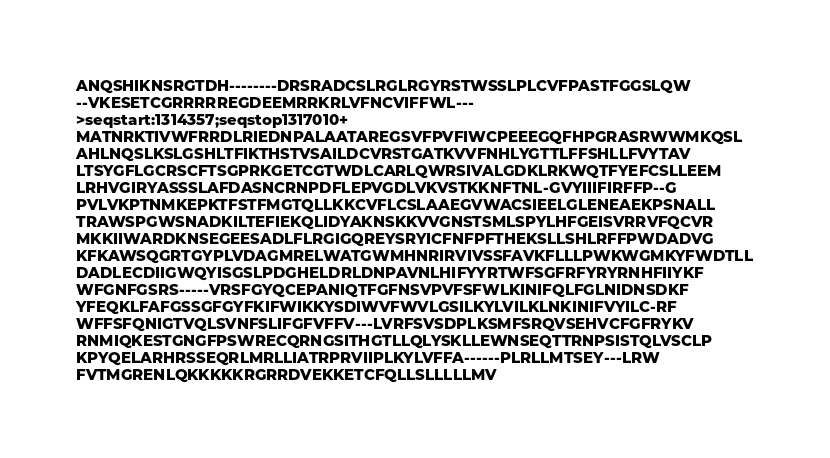<code> <loc_0><loc_0><loc_500><loc_500><_Perl_>ANQSHIKNSRGTDH--------DRSRADCSLRGLRGYRSTWSSLPLCVFPASTFGGSLQW
--VKESETCGRRRRREGDEEMRRKRLVFNCVIFFWL---
>seqstart:1314357;seqstop1317010+
MATNRKTIVWFRRDLRIEDNPALAATAREGSVFPVFIWCPEEEGQFHPGRASRWWMKQSL
AHLNQSLKSLGSHLTFIKTHSTVSAILDCVRSTGATKVVFNHLYGTTLFFSHLLFVYTAV
LTSYGFLGCRSCFTSGPRKGETCGTWDLCARLQWRSIVALGDKLRKWQTFYEFCSLLEEM
LRHVGIRYASSSLAFDASNCRNPDFLEPVGDLVKVSTKKNFTNL-GVYIIIFIRFFP--G
PVLVKPTNMKEPKTFSTFMGTQLLKKCVFLCSLAAEGVWACSIEELGLENEAEKPSNALL
TRAWSPGWSNADKILTEFIEKQLIDYAKNSKKVVGNSTSMLSPYLHFGEISVRRVFQCVR
MKKIIWARDKNSEGEESADLFLRGIGQREYSRYICFNFPFTHEKSLLSHLRFFPWDADVG
KFKAWSQGRTGYPLVDAGMRELWATGWMHNRIRVIVSSFAVKFLLLPWKWGMKYFWDTLL
DADLECDIIGWQYISGSLPDGHELDRLDNPAVNLHIFYYRTWFSGFRFYRYRNHFIIYKF
WFGNFGSRS-----VRSFGYQCEPANIQTFGFNSVPVFSFWLKINIFQLFGLNIDNSDKF
YFEQKLFAFGSSGFGYFKIFWIKKYSDIWVFWVLGSILKYLVILKLNKINIFVYILC-RF
WFFSFQNIGTVQLSVNFSLIFGFVFFV---LVRFSVSDPLKSMFSRQVSEHVCFGFRYKV
RNMIQKESTGNGFPSWRECQRNGSITHGTLLQLYSKLLEWNSEQTTRNPSISTQLVSCLP
KPYQELARHRSSEQRLMRLLIATRPRVIIPLKYLVFFA------PLRLLMTSEY---LRW
FVTMGRENLQKKKKKRGRRDVEKKETCFQLLSLLLLLMV
</code> 